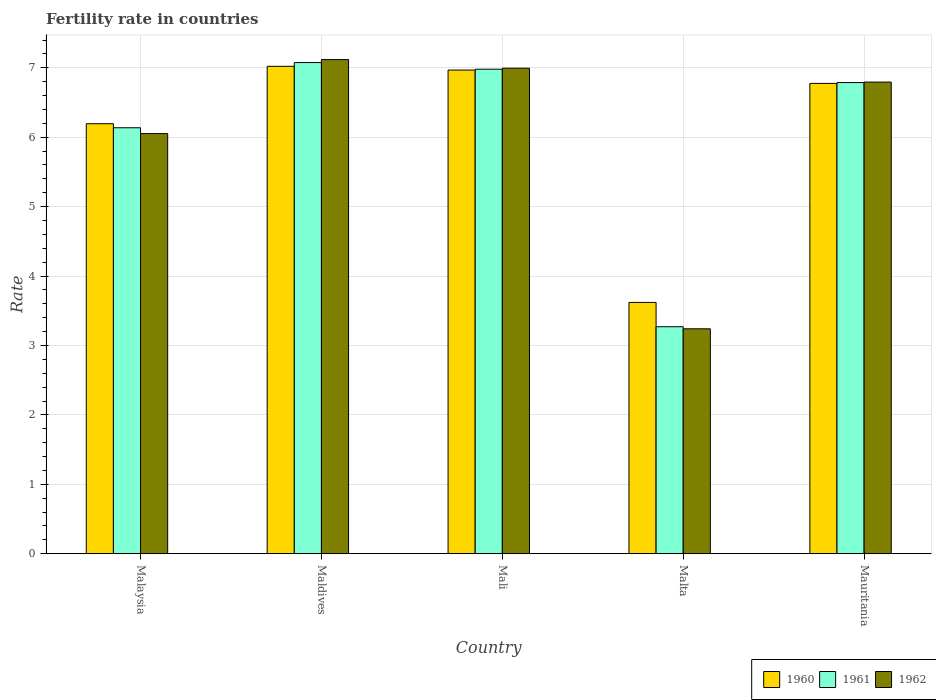How many different coloured bars are there?
Make the answer very short. 3. Are the number of bars per tick equal to the number of legend labels?
Offer a terse response. Yes. Are the number of bars on each tick of the X-axis equal?
Offer a very short reply. Yes. What is the label of the 2nd group of bars from the left?
Your answer should be compact. Maldives. In how many cases, is the number of bars for a given country not equal to the number of legend labels?
Make the answer very short. 0. What is the fertility rate in 1962 in Malaysia?
Give a very brief answer. 6.05. Across all countries, what is the maximum fertility rate in 1962?
Provide a short and direct response. 7.12. Across all countries, what is the minimum fertility rate in 1962?
Give a very brief answer. 3.24. In which country was the fertility rate in 1961 maximum?
Offer a terse response. Maldives. In which country was the fertility rate in 1960 minimum?
Give a very brief answer. Malta. What is the total fertility rate in 1962 in the graph?
Keep it short and to the point. 30.2. What is the difference between the fertility rate in 1961 in Mali and that in Mauritania?
Your answer should be compact. 0.19. What is the difference between the fertility rate in 1961 in Malaysia and the fertility rate in 1962 in Mali?
Offer a very short reply. -0.86. What is the average fertility rate in 1962 per country?
Provide a short and direct response. 6.04. What is the difference between the fertility rate of/in 1960 and fertility rate of/in 1961 in Mali?
Give a very brief answer. -0.01. What is the ratio of the fertility rate in 1961 in Mali to that in Malta?
Ensure brevity in your answer.  2.13. What is the difference between the highest and the second highest fertility rate in 1960?
Your answer should be very brief. -0.19. What is the difference between the highest and the lowest fertility rate in 1962?
Provide a short and direct response. 3.88. What does the 1st bar from the left in Maldives represents?
Ensure brevity in your answer.  1960. How many bars are there?
Ensure brevity in your answer.  15. Are the values on the major ticks of Y-axis written in scientific E-notation?
Keep it short and to the point. No. Does the graph contain any zero values?
Your answer should be compact. No. Does the graph contain grids?
Your response must be concise. Yes. How are the legend labels stacked?
Offer a very short reply. Horizontal. What is the title of the graph?
Your answer should be compact. Fertility rate in countries. Does "2005" appear as one of the legend labels in the graph?
Your answer should be compact. No. What is the label or title of the X-axis?
Your answer should be very brief. Country. What is the label or title of the Y-axis?
Provide a short and direct response. Rate. What is the Rate of 1960 in Malaysia?
Your answer should be very brief. 6.19. What is the Rate in 1961 in Malaysia?
Ensure brevity in your answer.  6.14. What is the Rate of 1962 in Malaysia?
Give a very brief answer. 6.05. What is the Rate of 1960 in Maldives?
Provide a succinct answer. 7.02. What is the Rate in 1961 in Maldives?
Keep it short and to the point. 7.08. What is the Rate in 1962 in Maldives?
Provide a short and direct response. 7.12. What is the Rate in 1960 in Mali?
Keep it short and to the point. 6.97. What is the Rate in 1961 in Mali?
Your response must be concise. 6.98. What is the Rate of 1962 in Mali?
Offer a terse response. 6.99. What is the Rate of 1960 in Malta?
Your answer should be compact. 3.62. What is the Rate of 1961 in Malta?
Offer a very short reply. 3.27. What is the Rate in 1962 in Malta?
Your answer should be very brief. 3.24. What is the Rate of 1960 in Mauritania?
Your response must be concise. 6.78. What is the Rate of 1961 in Mauritania?
Give a very brief answer. 6.79. What is the Rate in 1962 in Mauritania?
Make the answer very short. 6.79. Across all countries, what is the maximum Rate of 1960?
Ensure brevity in your answer.  7.02. Across all countries, what is the maximum Rate in 1961?
Provide a short and direct response. 7.08. Across all countries, what is the maximum Rate in 1962?
Give a very brief answer. 7.12. Across all countries, what is the minimum Rate in 1960?
Keep it short and to the point. 3.62. Across all countries, what is the minimum Rate in 1961?
Provide a succinct answer. 3.27. Across all countries, what is the minimum Rate of 1962?
Give a very brief answer. 3.24. What is the total Rate in 1960 in the graph?
Your answer should be compact. 30.58. What is the total Rate in 1961 in the graph?
Your answer should be very brief. 30.25. What is the total Rate in 1962 in the graph?
Keep it short and to the point. 30.2. What is the difference between the Rate in 1960 in Malaysia and that in Maldives?
Ensure brevity in your answer.  -0.83. What is the difference between the Rate of 1961 in Malaysia and that in Maldives?
Provide a short and direct response. -0.94. What is the difference between the Rate of 1962 in Malaysia and that in Maldives?
Your response must be concise. -1.07. What is the difference between the Rate of 1960 in Malaysia and that in Mali?
Provide a succinct answer. -0.77. What is the difference between the Rate in 1961 in Malaysia and that in Mali?
Make the answer very short. -0.84. What is the difference between the Rate in 1962 in Malaysia and that in Mali?
Your answer should be very brief. -0.94. What is the difference between the Rate in 1960 in Malaysia and that in Malta?
Offer a very short reply. 2.57. What is the difference between the Rate in 1961 in Malaysia and that in Malta?
Your answer should be very brief. 2.87. What is the difference between the Rate of 1962 in Malaysia and that in Malta?
Keep it short and to the point. 2.81. What is the difference between the Rate in 1960 in Malaysia and that in Mauritania?
Give a very brief answer. -0.58. What is the difference between the Rate of 1961 in Malaysia and that in Mauritania?
Make the answer very short. -0.65. What is the difference between the Rate in 1962 in Malaysia and that in Mauritania?
Your response must be concise. -0.74. What is the difference between the Rate in 1960 in Maldives and that in Mali?
Keep it short and to the point. 0.05. What is the difference between the Rate of 1961 in Maldives and that in Mali?
Your answer should be compact. 0.1. What is the difference between the Rate of 1962 in Maldives and that in Mali?
Provide a short and direct response. 0.12. What is the difference between the Rate of 1960 in Maldives and that in Malta?
Provide a succinct answer. 3.4. What is the difference between the Rate of 1961 in Maldives and that in Malta?
Offer a terse response. 3.81. What is the difference between the Rate in 1962 in Maldives and that in Malta?
Your answer should be compact. 3.88. What is the difference between the Rate in 1960 in Maldives and that in Mauritania?
Keep it short and to the point. 0.25. What is the difference between the Rate of 1961 in Maldives and that in Mauritania?
Offer a terse response. 0.29. What is the difference between the Rate of 1962 in Maldives and that in Mauritania?
Make the answer very short. 0.32. What is the difference between the Rate in 1960 in Mali and that in Malta?
Your answer should be very brief. 3.35. What is the difference between the Rate of 1961 in Mali and that in Malta?
Provide a succinct answer. 3.71. What is the difference between the Rate of 1962 in Mali and that in Malta?
Your answer should be compact. 3.75. What is the difference between the Rate of 1960 in Mali and that in Mauritania?
Provide a short and direct response. 0.19. What is the difference between the Rate of 1961 in Mali and that in Mauritania?
Give a very brief answer. 0.19. What is the difference between the Rate of 1962 in Mali and that in Mauritania?
Make the answer very short. 0.2. What is the difference between the Rate of 1960 in Malta and that in Mauritania?
Your answer should be compact. -3.15. What is the difference between the Rate of 1961 in Malta and that in Mauritania?
Your answer should be very brief. -3.52. What is the difference between the Rate of 1962 in Malta and that in Mauritania?
Your response must be concise. -3.55. What is the difference between the Rate of 1960 in Malaysia and the Rate of 1961 in Maldives?
Provide a short and direct response. -0.88. What is the difference between the Rate in 1960 in Malaysia and the Rate in 1962 in Maldives?
Ensure brevity in your answer.  -0.92. What is the difference between the Rate of 1961 in Malaysia and the Rate of 1962 in Maldives?
Provide a short and direct response. -0.98. What is the difference between the Rate in 1960 in Malaysia and the Rate in 1961 in Mali?
Ensure brevity in your answer.  -0.79. What is the difference between the Rate in 1961 in Malaysia and the Rate in 1962 in Mali?
Your answer should be compact. -0.86. What is the difference between the Rate in 1960 in Malaysia and the Rate in 1961 in Malta?
Provide a short and direct response. 2.92. What is the difference between the Rate in 1960 in Malaysia and the Rate in 1962 in Malta?
Offer a terse response. 2.95. What is the difference between the Rate in 1961 in Malaysia and the Rate in 1962 in Malta?
Offer a very short reply. 2.9. What is the difference between the Rate in 1960 in Malaysia and the Rate in 1961 in Mauritania?
Provide a short and direct response. -0.59. What is the difference between the Rate of 1961 in Malaysia and the Rate of 1962 in Mauritania?
Offer a very short reply. -0.66. What is the difference between the Rate of 1960 in Maldives and the Rate of 1961 in Mali?
Give a very brief answer. 0.04. What is the difference between the Rate in 1960 in Maldives and the Rate in 1962 in Mali?
Your answer should be compact. 0.03. What is the difference between the Rate of 1961 in Maldives and the Rate of 1962 in Mali?
Ensure brevity in your answer.  0.08. What is the difference between the Rate of 1960 in Maldives and the Rate of 1961 in Malta?
Give a very brief answer. 3.75. What is the difference between the Rate in 1960 in Maldives and the Rate in 1962 in Malta?
Provide a succinct answer. 3.78. What is the difference between the Rate in 1961 in Maldives and the Rate in 1962 in Malta?
Your answer should be compact. 3.83. What is the difference between the Rate in 1960 in Maldives and the Rate in 1961 in Mauritania?
Keep it short and to the point. 0.23. What is the difference between the Rate in 1960 in Maldives and the Rate in 1962 in Mauritania?
Give a very brief answer. 0.23. What is the difference between the Rate in 1961 in Maldives and the Rate in 1962 in Mauritania?
Provide a short and direct response. 0.28. What is the difference between the Rate of 1960 in Mali and the Rate of 1961 in Malta?
Provide a short and direct response. 3.7. What is the difference between the Rate of 1960 in Mali and the Rate of 1962 in Malta?
Make the answer very short. 3.73. What is the difference between the Rate in 1961 in Mali and the Rate in 1962 in Malta?
Offer a very short reply. 3.74. What is the difference between the Rate of 1960 in Mali and the Rate of 1961 in Mauritania?
Offer a very short reply. 0.18. What is the difference between the Rate of 1960 in Mali and the Rate of 1962 in Mauritania?
Your answer should be very brief. 0.17. What is the difference between the Rate of 1961 in Mali and the Rate of 1962 in Mauritania?
Your response must be concise. 0.18. What is the difference between the Rate of 1960 in Malta and the Rate of 1961 in Mauritania?
Your answer should be very brief. -3.17. What is the difference between the Rate of 1960 in Malta and the Rate of 1962 in Mauritania?
Give a very brief answer. -3.17. What is the difference between the Rate of 1961 in Malta and the Rate of 1962 in Mauritania?
Offer a terse response. -3.52. What is the average Rate in 1960 per country?
Offer a terse response. 6.12. What is the average Rate of 1961 per country?
Ensure brevity in your answer.  6.05. What is the average Rate of 1962 per country?
Your answer should be compact. 6.04. What is the difference between the Rate of 1960 and Rate of 1961 in Malaysia?
Your answer should be compact. 0.06. What is the difference between the Rate of 1960 and Rate of 1962 in Malaysia?
Ensure brevity in your answer.  0.14. What is the difference between the Rate in 1961 and Rate in 1962 in Malaysia?
Offer a very short reply. 0.08. What is the difference between the Rate of 1960 and Rate of 1961 in Maldives?
Provide a succinct answer. -0.05. What is the difference between the Rate of 1960 and Rate of 1962 in Maldives?
Provide a short and direct response. -0.1. What is the difference between the Rate of 1961 and Rate of 1962 in Maldives?
Your answer should be very brief. -0.04. What is the difference between the Rate in 1960 and Rate in 1961 in Mali?
Your response must be concise. -0.01. What is the difference between the Rate in 1960 and Rate in 1962 in Mali?
Your answer should be very brief. -0.03. What is the difference between the Rate of 1961 and Rate of 1962 in Mali?
Your answer should be very brief. -0.01. What is the difference between the Rate in 1960 and Rate in 1961 in Malta?
Your answer should be compact. 0.35. What is the difference between the Rate in 1960 and Rate in 1962 in Malta?
Offer a very short reply. 0.38. What is the difference between the Rate in 1960 and Rate in 1961 in Mauritania?
Give a very brief answer. -0.01. What is the difference between the Rate of 1960 and Rate of 1962 in Mauritania?
Your answer should be compact. -0.02. What is the difference between the Rate in 1961 and Rate in 1962 in Mauritania?
Offer a terse response. -0.01. What is the ratio of the Rate of 1960 in Malaysia to that in Maldives?
Give a very brief answer. 0.88. What is the ratio of the Rate of 1961 in Malaysia to that in Maldives?
Offer a very short reply. 0.87. What is the ratio of the Rate in 1962 in Malaysia to that in Maldives?
Make the answer very short. 0.85. What is the ratio of the Rate of 1960 in Malaysia to that in Mali?
Ensure brevity in your answer.  0.89. What is the ratio of the Rate of 1961 in Malaysia to that in Mali?
Offer a very short reply. 0.88. What is the ratio of the Rate of 1962 in Malaysia to that in Mali?
Provide a short and direct response. 0.87. What is the ratio of the Rate of 1960 in Malaysia to that in Malta?
Your answer should be compact. 1.71. What is the ratio of the Rate of 1961 in Malaysia to that in Malta?
Offer a very short reply. 1.88. What is the ratio of the Rate in 1962 in Malaysia to that in Malta?
Provide a short and direct response. 1.87. What is the ratio of the Rate of 1960 in Malaysia to that in Mauritania?
Provide a succinct answer. 0.91. What is the ratio of the Rate of 1961 in Malaysia to that in Mauritania?
Provide a succinct answer. 0.9. What is the ratio of the Rate of 1962 in Malaysia to that in Mauritania?
Provide a succinct answer. 0.89. What is the ratio of the Rate in 1961 in Maldives to that in Mali?
Keep it short and to the point. 1.01. What is the ratio of the Rate in 1962 in Maldives to that in Mali?
Your answer should be compact. 1.02. What is the ratio of the Rate in 1960 in Maldives to that in Malta?
Ensure brevity in your answer.  1.94. What is the ratio of the Rate of 1961 in Maldives to that in Malta?
Your response must be concise. 2.16. What is the ratio of the Rate in 1962 in Maldives to that in Malta?
Keep it short and to the point. 2.2. What is the ratio of the Rate in 1960 in Maldives to that in Mauritania?
Give a very brief answer. 1.04. What is the ratio of the Rate in 1961 in Maldives to that in Mauritania?
Give a very brief answer. 1.04. What is the ratio of the Rate in 1962 in Maldives to that in Mauritania?
Ensure brevity in your answer.  1.05. What is the ratio of the Rate of 1960 in Mali to that in Malta?
Offer a very short reply. 1.92. What is the ratio of the Rate in 1961 in Mali to that in Malta?
Give a very brief answer. 2.13. What is the ratio of the Rate of 1962 in Mali to that in Malta?
Make the answer very short. 2.16. What is the ratio of the Rate of 1960 in Mali to that in Mauritania?
Keep it short and to the point. 1.03. What is the ratio of the Rate in 1961 in Mali to that in Mauritania?
Offer a very short reply. 1.03. What is the ratio of the Rate of 1962 in Mali to that in Mauritania?
Your response must be concise. 1.03. What is the ratio of the Rate in 1960 in Malta to that in Mauritania?
Offer a terse response. 0.53. What is the ratio of the Rate of 1961 in Malta to that in Mauritania?
Provide a short and direct response. 0.48. What is the ratio of the Rate of 1962 in Malta to that in Mauritania?
Your answer should be very brief. 0.48. What is the difference between the highest and the second highest Rate in 1960?
Give a very brief answer. 0.05. What is the difference between the highest and the second highest Rate in 1961?
Provide a short and direct response. 0.1. What is the difference between the highest and the second highest Rate in 1962?
Make the answer very short. 0.12. What is the difference between the highest and the lowest Rate in 1960?
Your answer should be compact. 3.4. What is the difference between the highest and the lowest Rate in 1961?
Keep it short and to the point. 3.81. What is the difference between the highest and the lowest Rate of 1962?
Provide a short and direct response. 3.88. 